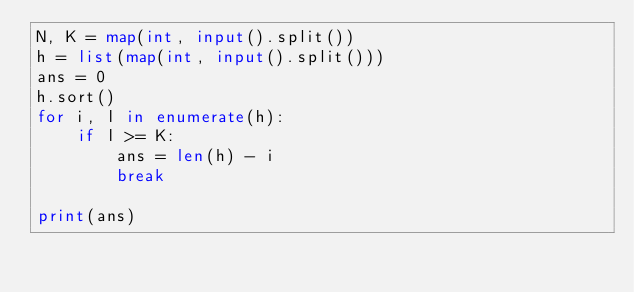<code> <loc_0><loc_0><loc_500><loc_500><_Python_>N, K = map(int, input().split())
h = list(map(int, input().split()))
ans = 0
h.sort()
for i, l in enumerate(h):
    if l >= K:
        ans = len(h) - i
        break

print(ans)
</code> 